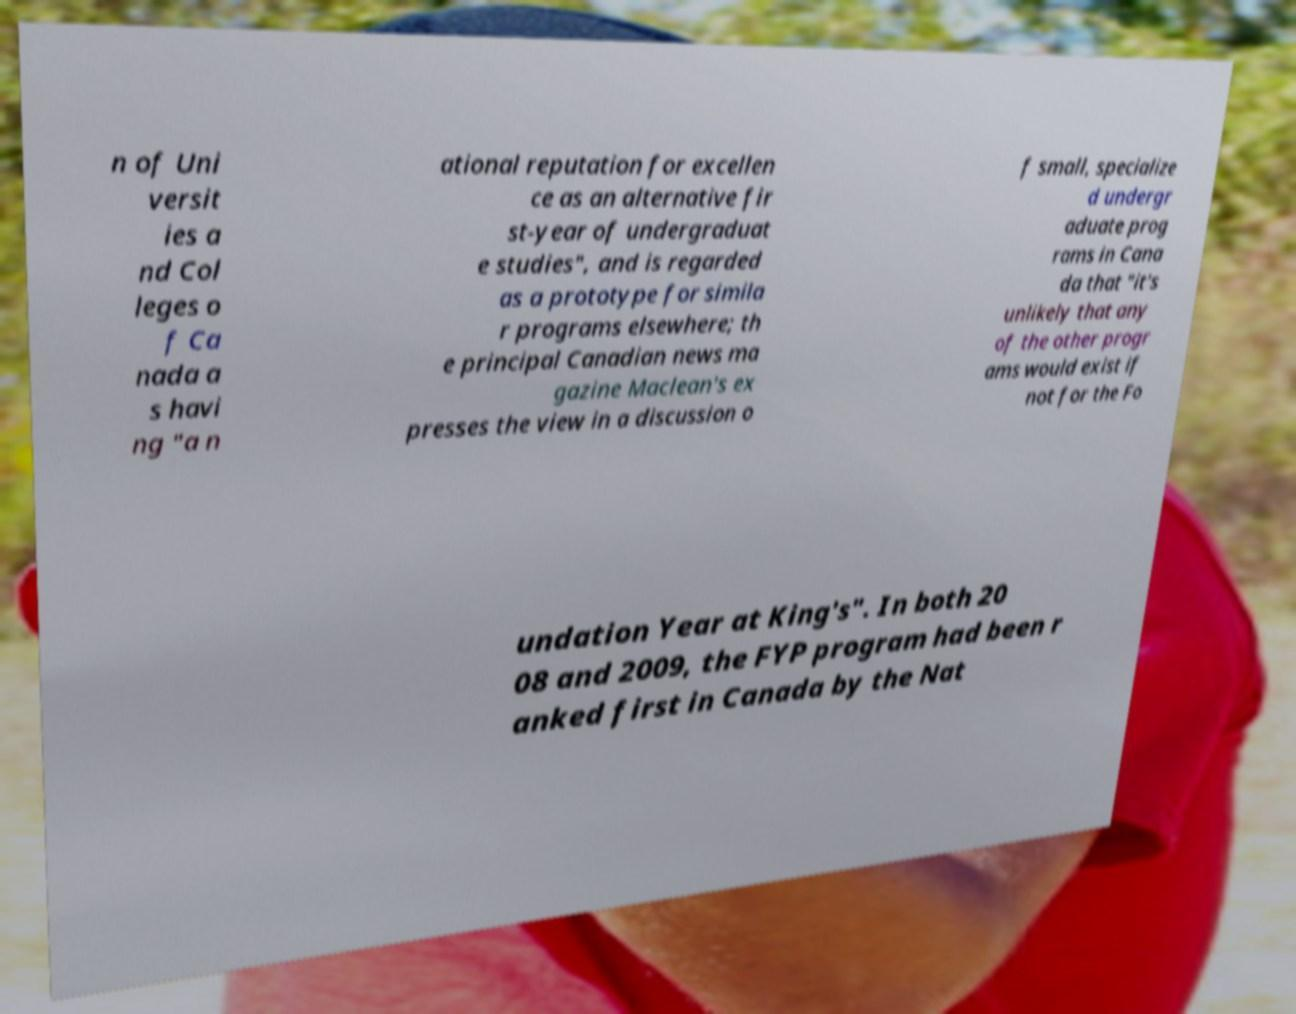I need the written content from this picture converted into text. Can you do that? n of Uni versit ies a nd Col leges o f Ca nada a s havi ng "a n ational reputation for excellen ce as an alternative fir st-year of undergraduat e studies", and is regarded as a prototype for simila r programs elsewhere; th e principal Canadian news ma gazine Maclean's ex presses the view in a discussion o f small, specialize d undergr aduate prog rams in Cana da that "it's unlikely that any of the other progr ams would exist if not for the Fo undation Year at King's". In both 20 08 and 2009, the FYP program had been r anked first in Canada by the Nat 